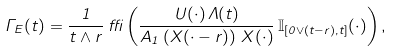<formula> <loc_0><loc_0><loc_500><loc_500>\Gamma _ { E } ( t ) = \frac { \ 1 \ } { t \wedge r } \, \delta \left ( \frac { U ( \cdot ) \, \Lambda ( t ) } { A _ { 1 } \left ( X ( \cdot - r ) \right ) \, X ( \cdot ) } \, \mathbb { I } _ { [ 0 \vee ( t - r ) , t ] } ( \cdot ) \right ) ,</formula> 